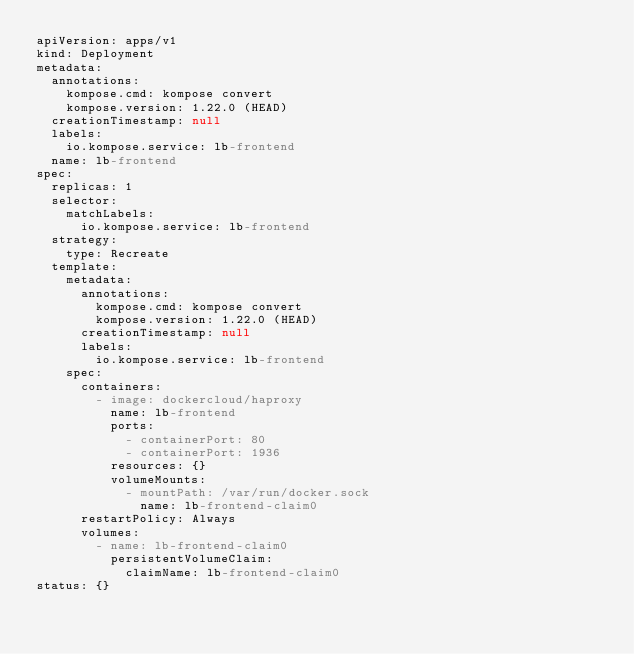<code> <loc_0><loc_0><loc_500><loc_500><_YAML_>apiVersion: apps/v1
kind: Deployment
metadata:
  annotations:
    kompose.cmd: kompose convert
    kompose.version: 1.22.0 (HEAD)
  creationTimestamp: null
  labels:
    io.kompose.service: lb-frontend
  name: lb-frontend
spec:
  replicas: 1
  selector:
    matchLabels:
      io.kompose.service: lb-frontend
  strategy:
    type: Recreate
  template:
    metadata:
      annotations:
        kompose.cmd: kompose convert
        kompose.version: 1.22.0 (HEAD)
      creationTimestamp: null
      labels:
        io.kompose.service: lb-frontend
    spec:
      containers:
        - image: dockercloud/haproxy
          name: lb-frontend
          ports:
            - containerPort: 80
            - containerPort: 1936
          resources: {}
          volumeMounts:
            - mountPath: /var/run/docker.sock
              name: lb-frontend-claim0
      restartPolicy: Always
      volumes:
        - name: lb-frontend-claim0
          persistentVolumeClaim:
            claimName: lb-frontend-claim0
status: {}
</code> 